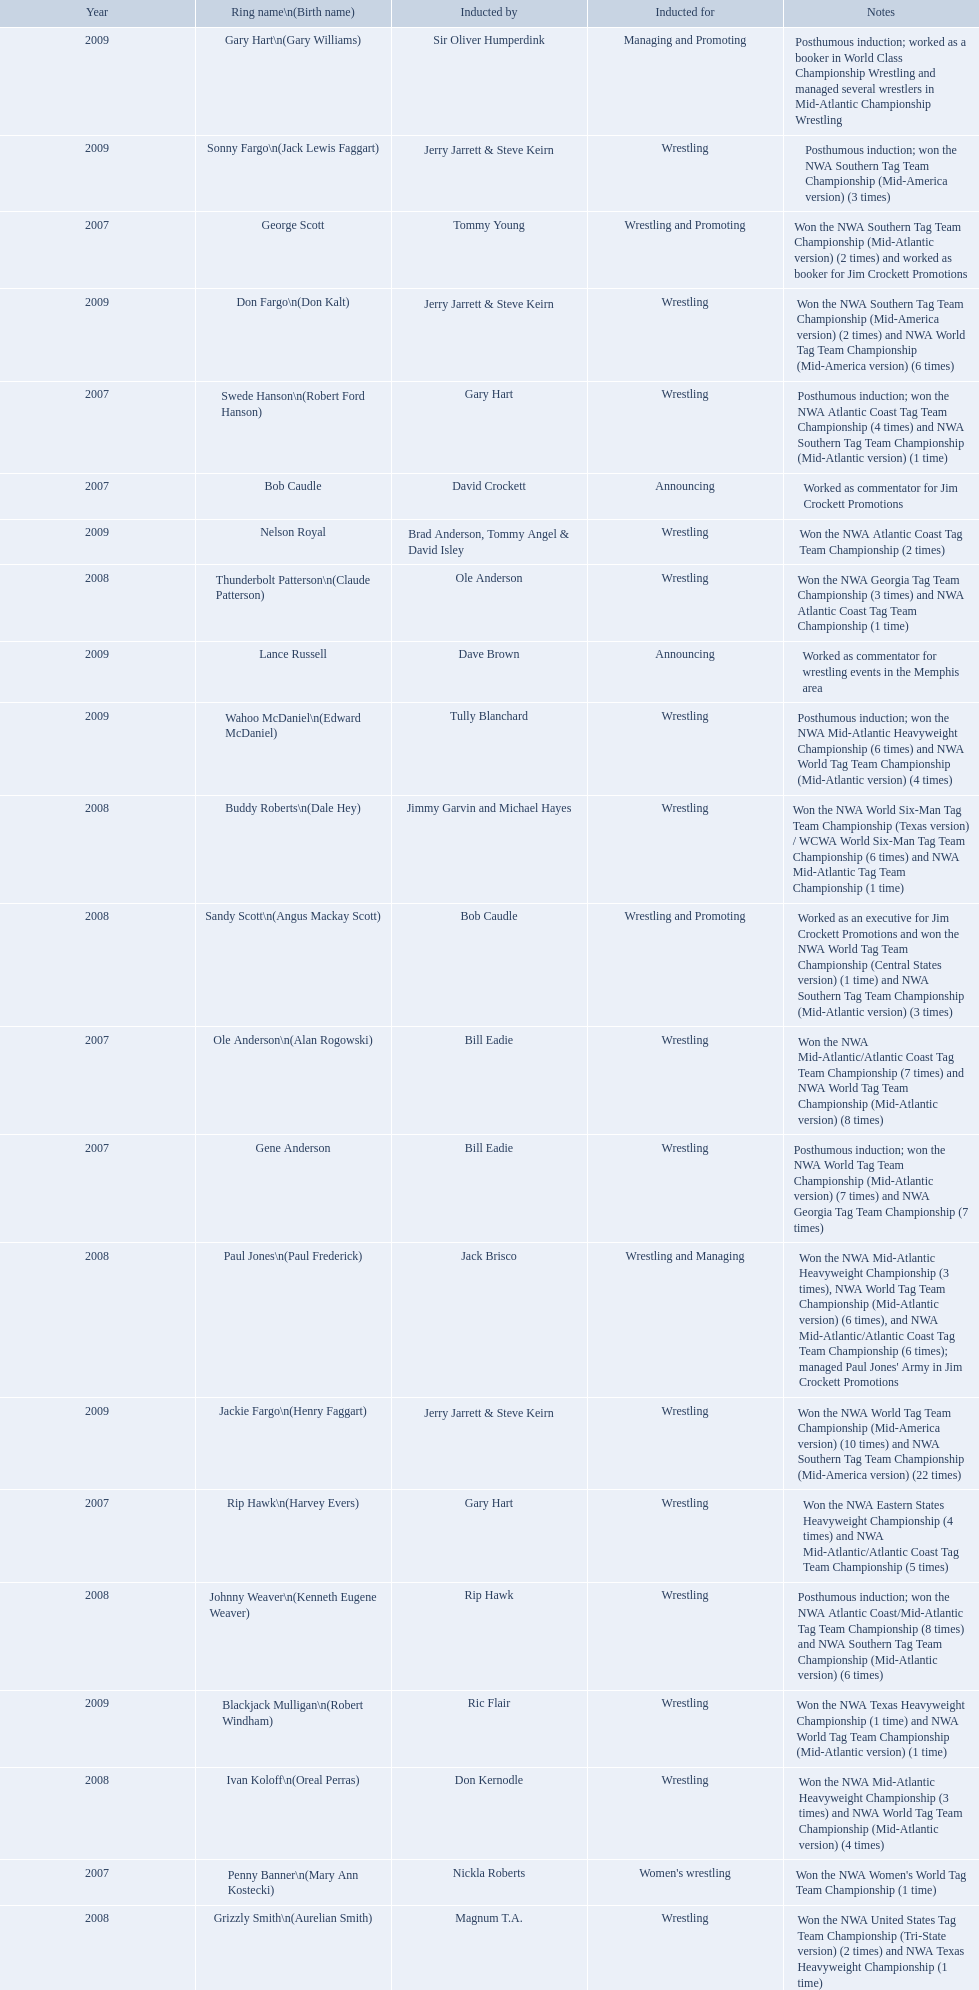Who was the announcer inducted into the hall of heroes in 2007? Bob Caudle. Who was the next announcer to be inducted? Lance Russell. What year was the induction held? 2007. Which inductee was not alive? Gene Anderson. 